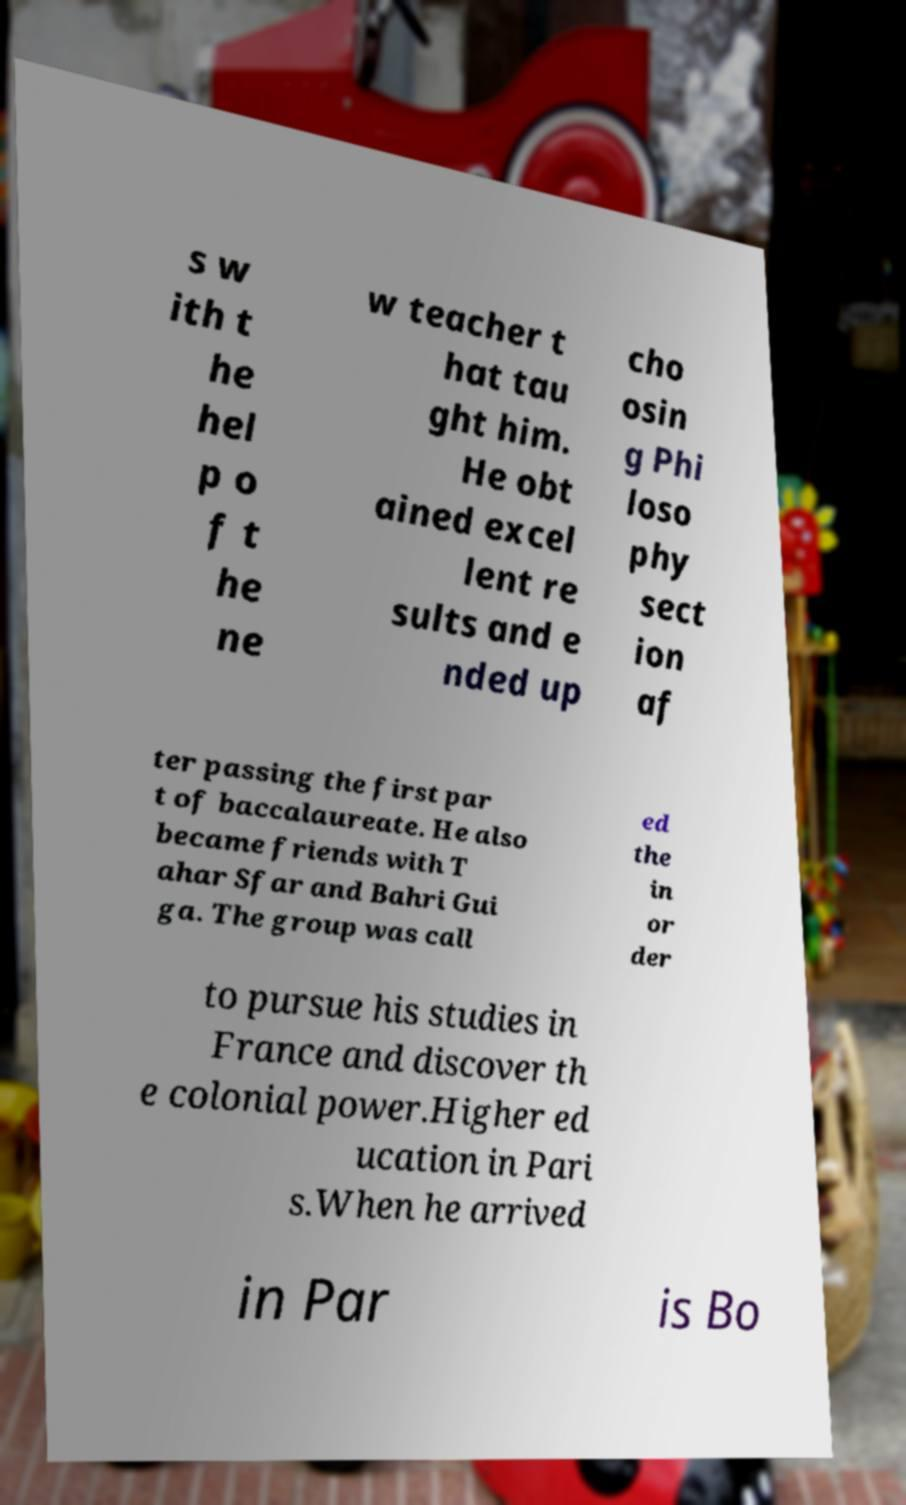Can you accurately transcribe the text from the provided image for me? s w ith t he hel p o f t he ne w teacher t hat tau ght him. He obt ained excel lent re sults and e nded up cho osin g Phi loso phy sect ion af ter passing the first par t of baccalaureate. He also became friends with T ahar Sfar and Bahri Gui ga. The group was call ed the in or der to pursue his studies in France and discover th e colonial power.Higher ed ucation in Pari s.When he arrived in Par is Bo 